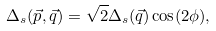<formula> <loc_0><loc_0><loc_500><loc_500>\Delta _ { s } ( \vec { p } , \vec { q } ) = \sqrt { 2 } \Delta _ { s } ( \vec { q } ) \cos ( 2 \phi ) ,</formula> 